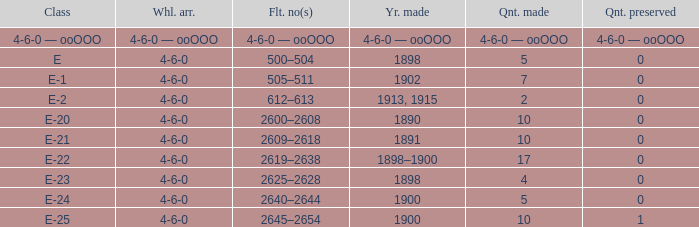Would you be able to parse every entry in this table? {'header': ['Class', 'Whl. arr.', 'Flt. no(s)', 'Yr. made', 'Qnt. made', 'Qnt. preserved'], 'rows': [['4-6-0 — ooOOO', '4-6-0 — ooOOO', '4-6-0 — ooOOO', '4-6-0 — ooOOO', '4-6-0 — ooOOO', '4-6-0 — ooOOO'], ['E', '4-6-0', '500–504', '1898', '5', '0'], ['E-1', '4-6-0', '505–511', '1902', '7', '0'], ['E-2', '4-6-0', '612–613', '1913, 1915', '2', '0'], ['E-20', '4-6-0', '2600–2608', '1890', '10', '0'], ['E-21', '4-6-0', '2609–2618', '1891', '10', '0'], ['E-22', '4-6-0', '2619–2638', '1898–1900', '17', '0'], ['E-23', '4-6-0', '2625–2628', '1898', '4', '0'], ['E-24', '4-6-0', '2640–2644', '1900', '5', '0'], ['E-25', '4-6-0', '2645–2654', '1900', '10', '1']]} Which fleet number is associated with a 4-6-0 wheel layout manufactured in 1890? 2600–2608. 